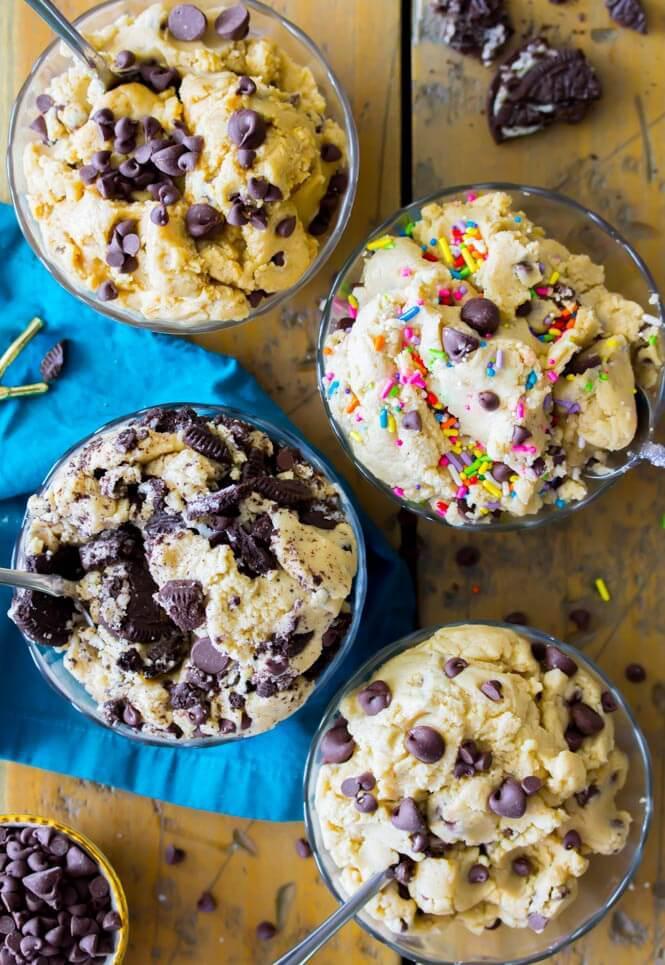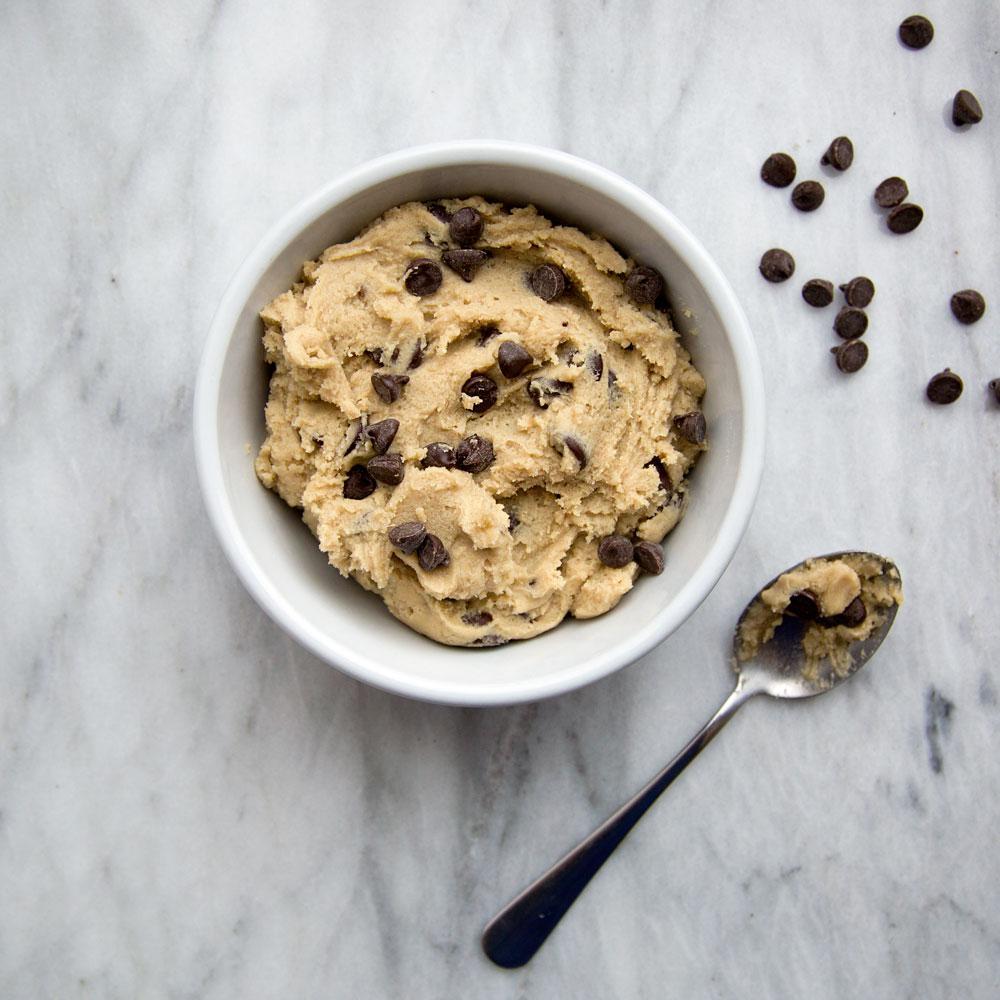The first image is the image on the left, the second image is the image on the right. Analyze the images presented: Is the assertion "A spoon is laying on the table." valid? Answer yes or no. Yes. The first image is the image on the left, the second image is the image on the right. Evaluate the accuracy of this statement regarding the images: "There is a single glass bowl holding chocolate chip cookie dough.". Is it true? Answer yes or no. No. 